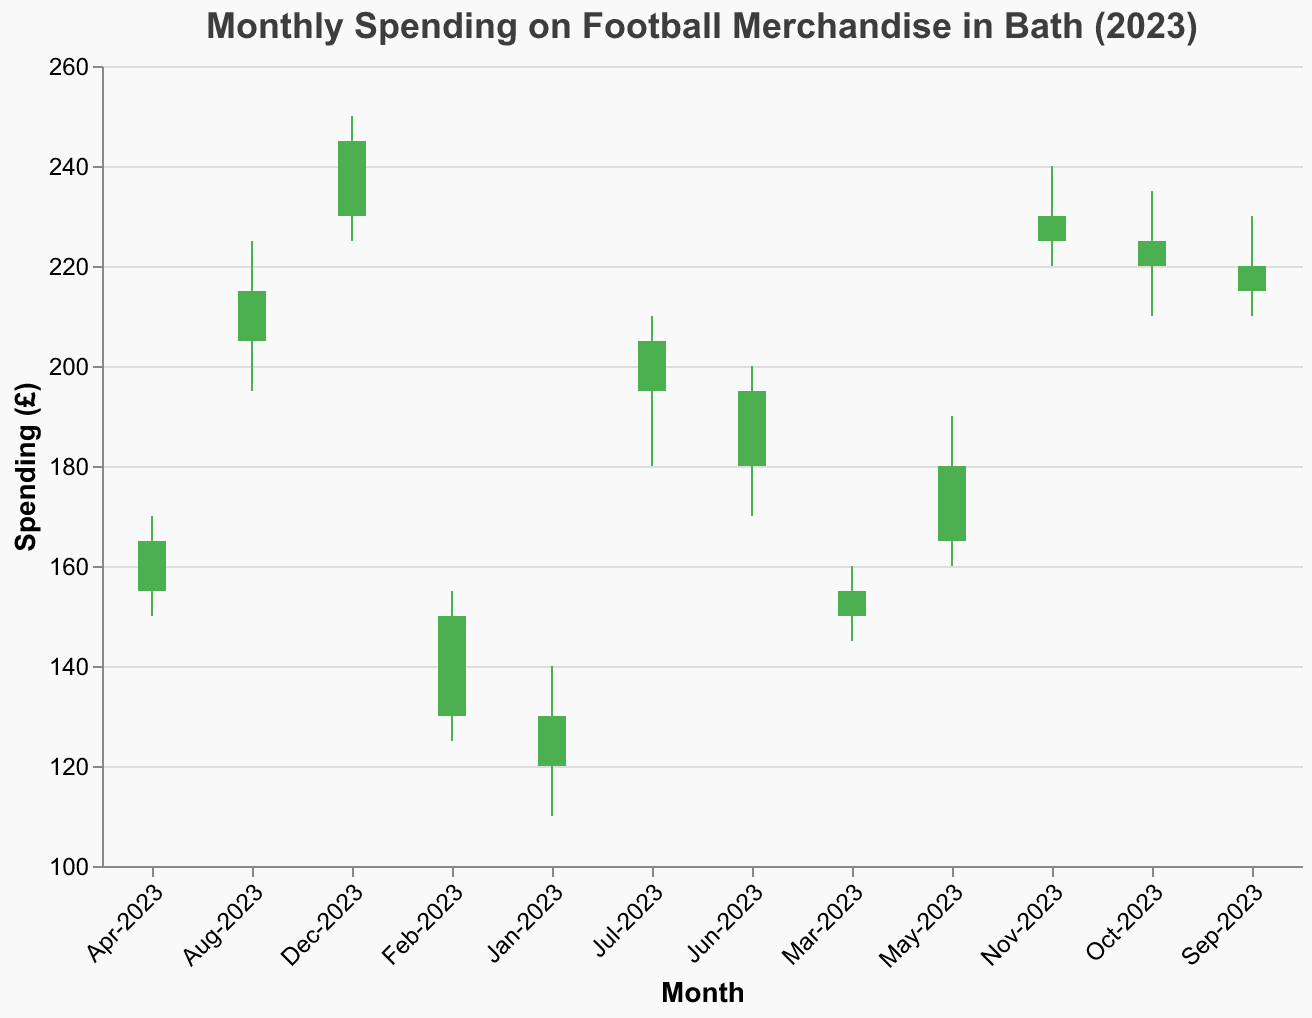What is the title of the plot? The title is typically located at the top center of the plot and visually stands out due to its larger font size and bold styling.
Answer: "Monthly Spending on Football Merchandise in Bath (2023)" What is the spending value in June 2023 when it closed? The closing values are the "Close" values in the dataset. For June 2023, it closed at £195.
Answer: £195 Which month had the highest spending and what was the value? Reviewing the "High" values, December 2023 has the highest spending value of £250.
Answer: December 2023, £250 In which month was there a drop in spending from open to close? A drop in spending from open to close is indicated when the "Close" value is less than the "Open" value. Checking the dataset, no month had a drop (all green).
Answer: None What was the range of spending in May 2023? The range can be found by subtracting the "Low" value from the "High" value for May 2023. The high was £190, and the low was £160, making the range £190 - £160 = £30.
Answer: £30 By how much did the spending increase from January 2023 to December 2023? To calculate the increase, subtract the spending in January 2023 from that in December 2023. The January 2023 value was £130, and December 2023 was £245. Therefore, £245 - £130 = £115.
Answer: £115 Which month had the smallest range in spending? The smallest range can be identified by finding the difference between the "High" and "Low" values for each month and locating the smallest value. For March 2023, the range was £160 - £145 = £15, which is the smallest.
Answer: March 2023 What is the total sum of the high spending values for the first quarter of 2023? Sum the "High" values for Jan-2023, Feb-2023, and Mar-2023 which are £140, £155, and £160 respectively. The total sum is £140 + £155 + £160 = £455.
Answer: £455 In which month did the spending increase the most compared to the previous month? Calculate the difference between the closing values of each month compared to the previous month and find the maximum. The biggest increase was from May to June (jumping from £180 to £195, an increase of £15).
Answer: June 2023 How many months showed an increase in spending from start to end of the month? Count the months where the "Close" value is greater than the "Open" value. All months in the dataset show such increases (12 months).
Answer: 12 